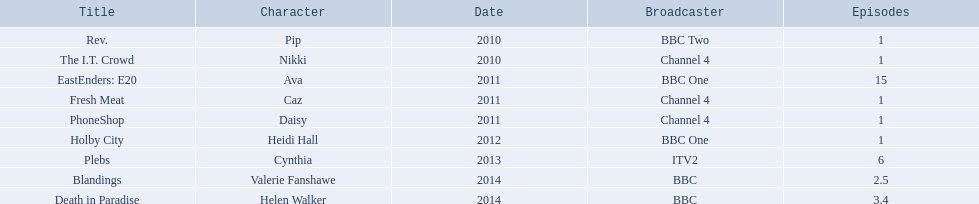How many episodes did sophie colquhoun star in on rev.? 1. What character did she play on phoneshop? Daisy. What role did she play on itv2? Cynthia. 